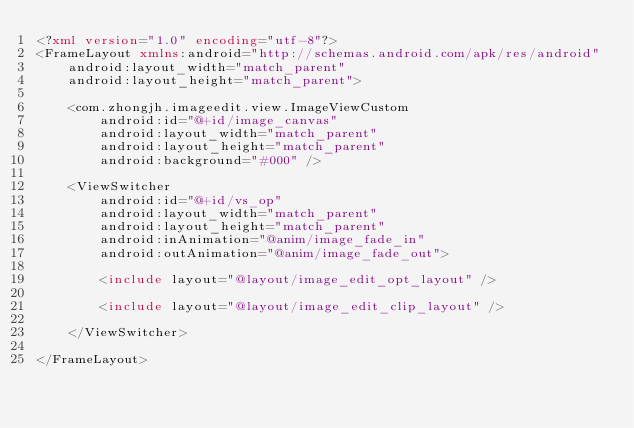Convert code to text. <code><loc_0><loc_0><loc_500><loc_500><_XML_><?xml version="1.0" encoding="utf-8"?>
<FrameLayout xmlns:android="http://schemas.android.com/apk/res/android"
    android:layout_width="match_parent"
    android:layout_height="match_parent">

    <com.zhongjh.imageedit.view.ImageViewCustom
        android:id="@+id/image_canvas"
        android:layout_width="match_parent"
        android:layout_height="match_parent"
        android:background="#000" />

    <ViewSwitcher
        android:id="@+id/vs_op"
        android:layout_width="match_parent"
        android:layout_height="match_parent"
        android:inAnimation="@anim/image_fade_in"
        android:outAnimation="@anim/image_fade_out">

        <include layout="@layout/image_edit_opt_layout" />

        <include layout="@layout/image_edit_clip_layout" />

    </ViewSwitcher>

</FrameLayout></code> 